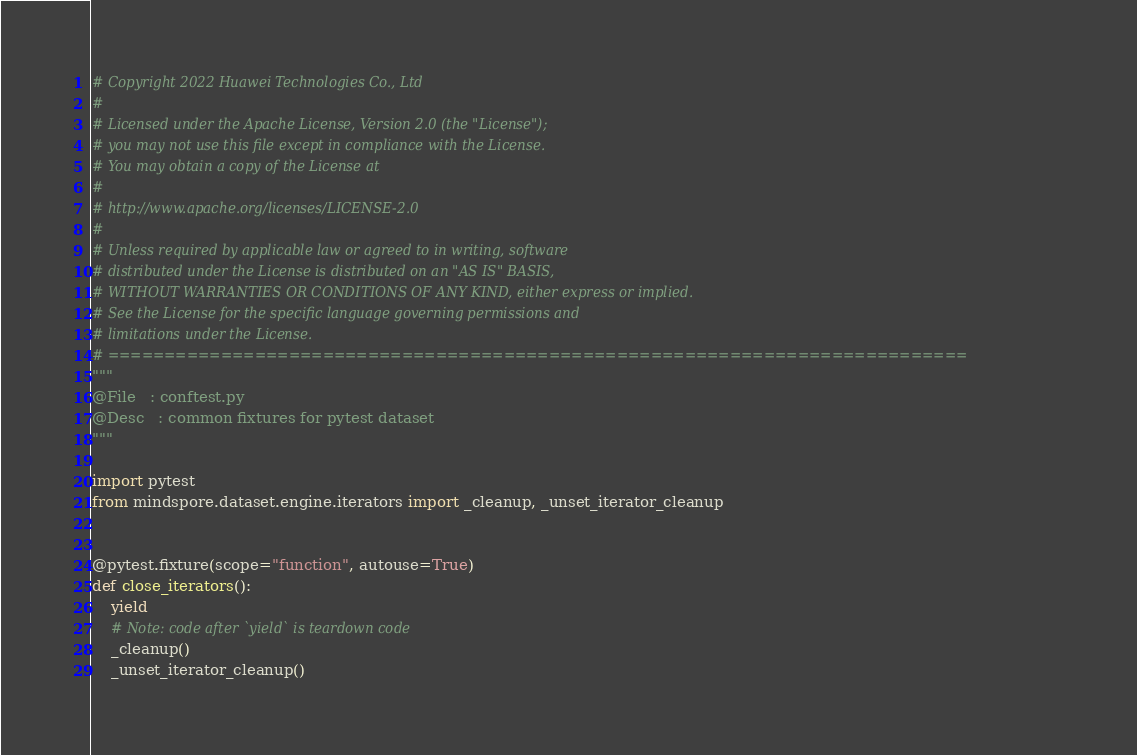<code> <loc_0><loc_0><loc_500><loc_500><_Python_># Copyright 2022 Huawei Technologies Co., Ltd
#
# Licensed under the Apache License, Version 2.0 (the "License");
# you may not use this file except in compliance with the License.
# You may obtain a copy of the License at
#
# http://www.apache.org/licenses/LICENSE-2.0
#
# Unless required by applicable law or agreed to in writing, software
# distributed under the License is distributed on an "AS IS" BASIS,
# WITHOUT WARRANTIES OR CONDITIONS OF ANY KIND, either express or implied.
# See the License for the specific language governing permissions and
# limitations under the License.
# ============================================================================
"""
@File   : conftest.py
@Desc   : common fixtures for pytest dataset
"""

import pytest
from mindspore.dataset.engine.iterators import _cleanup, _unset_iterator_cleanup


@pytest.fixture(scope="function", autouse=True)
def close_iterators():
    yield
    # Note: code after `yield` is teardown code
    _cleanup()
    _unset_iterator_cleanup()
</code> 